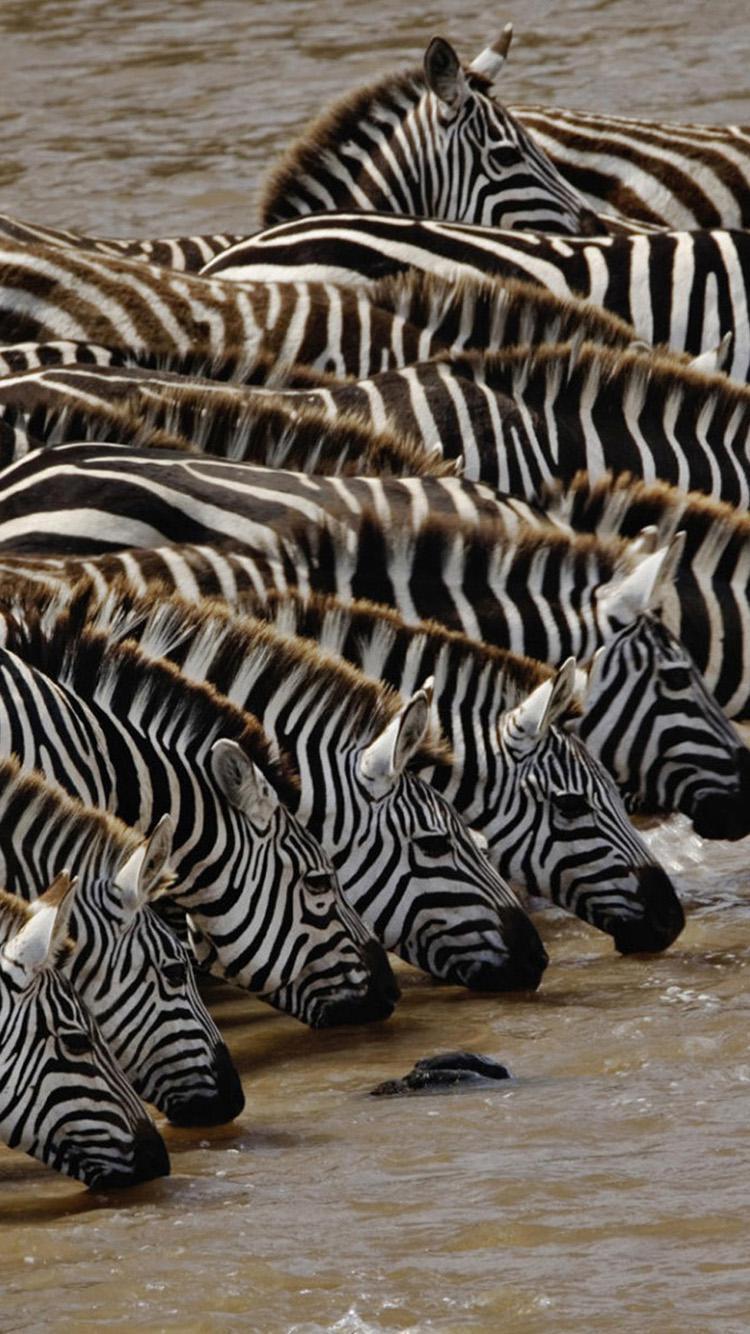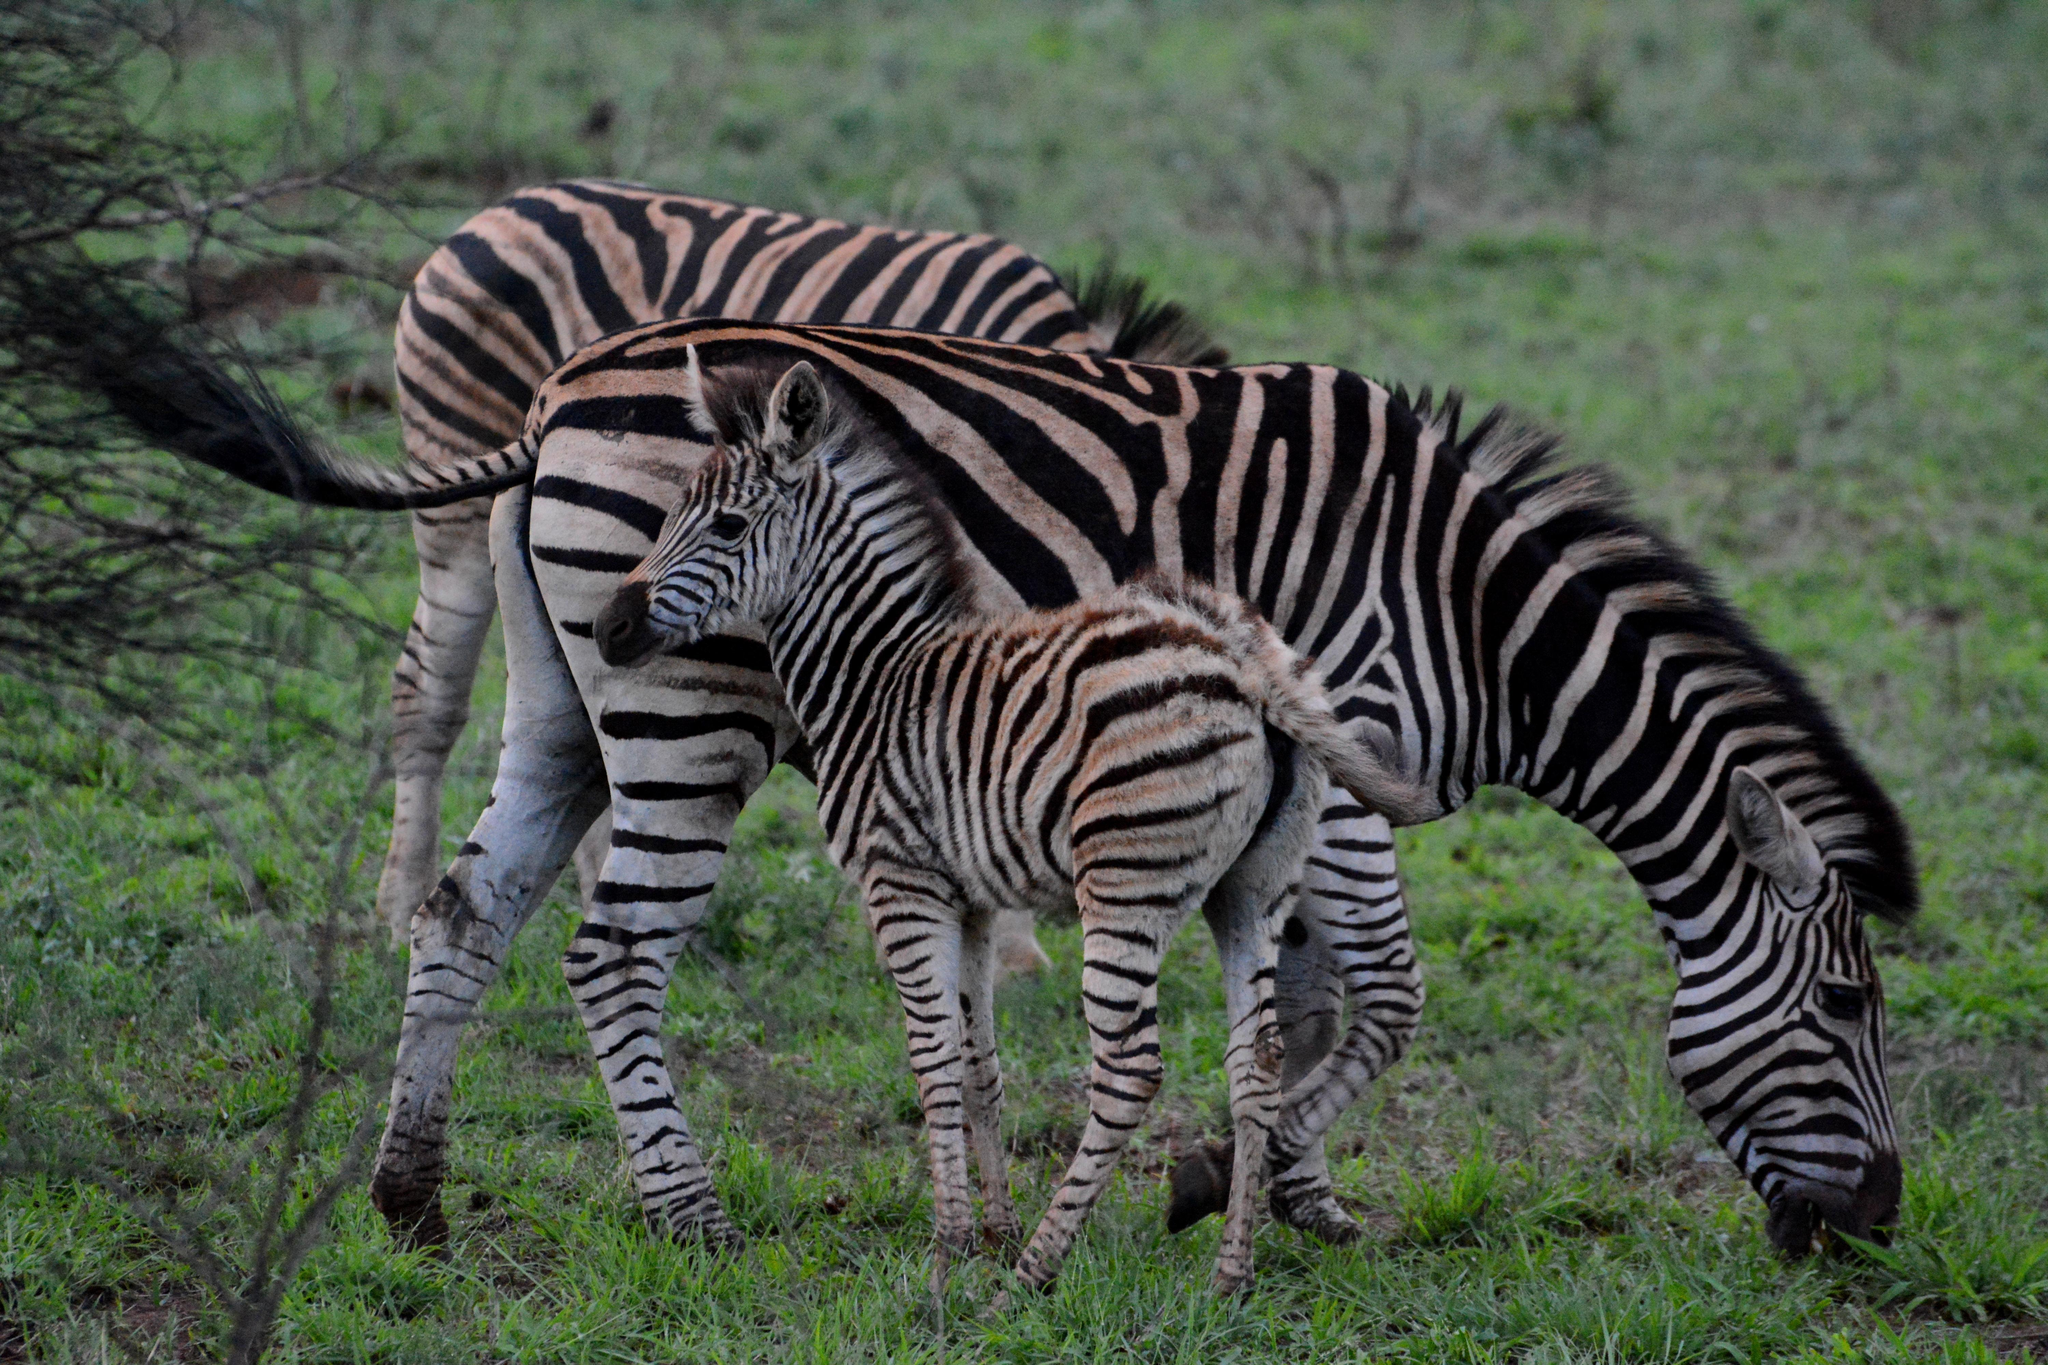The first image is the image on the left, the second image is the image on the right. For the images shown, is this caption "The right image contains no more than two zebras." true? Answer yes or no. No. 